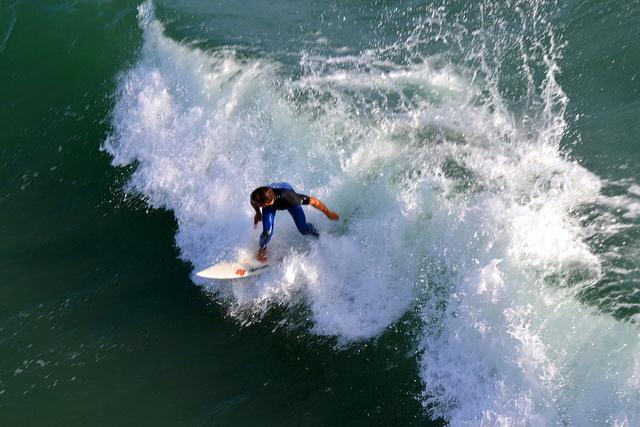What is the surfer wearing?
Keep it brief. Wetsuit. What color is the water?
Answer briefly. Green. What is he doing?
Be succinct. Surfing. Where is he?
Write a very short answer. Ocean. 